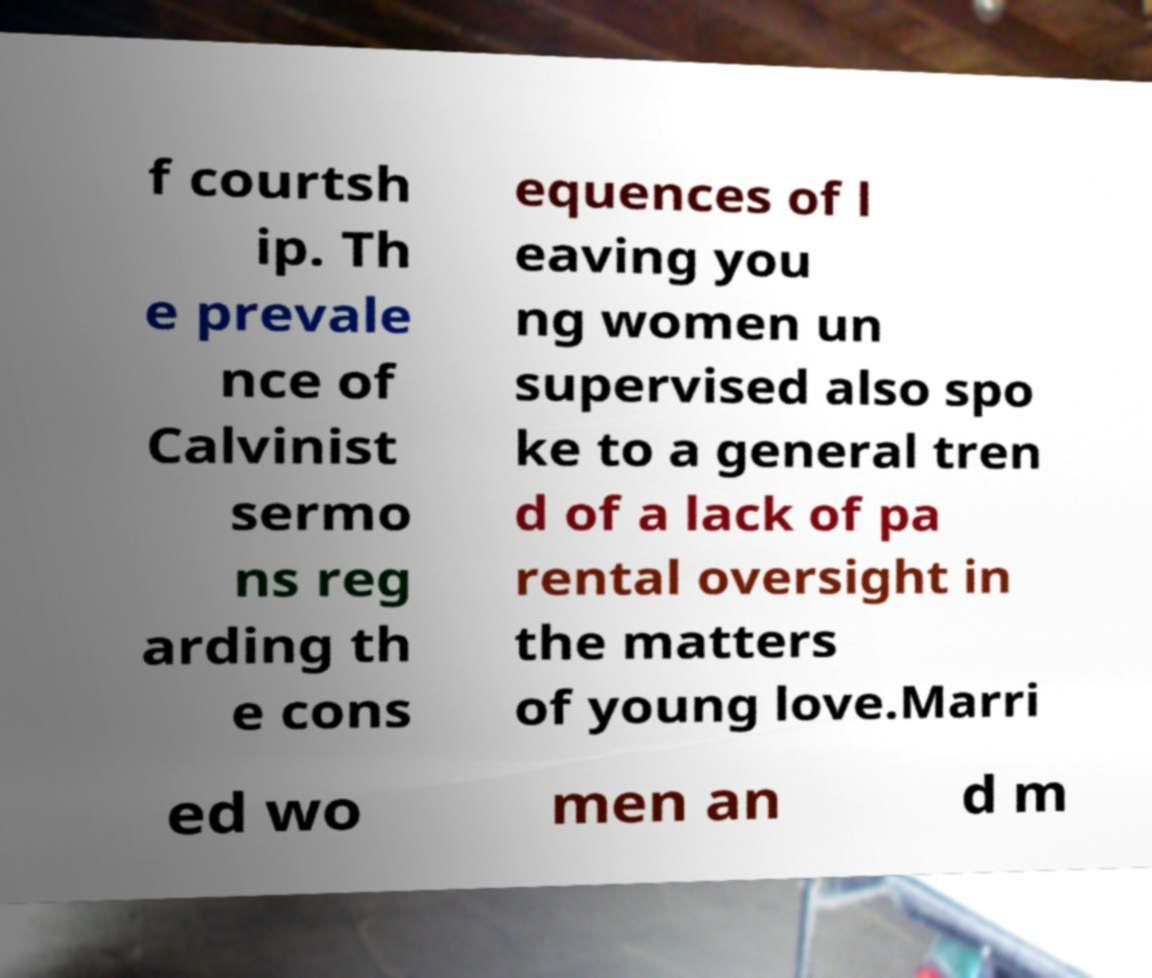I need the written content from this picture converted into text. Can you do that? f courtsh ip. Th e prevale nce of Calvinist sermo ns reg arding th e cons equences of l eaving you ng women un supervised also spo ke to a general tren d of a lack of pa rental oversight in the matters of young love.Marri ed wo men an d m 